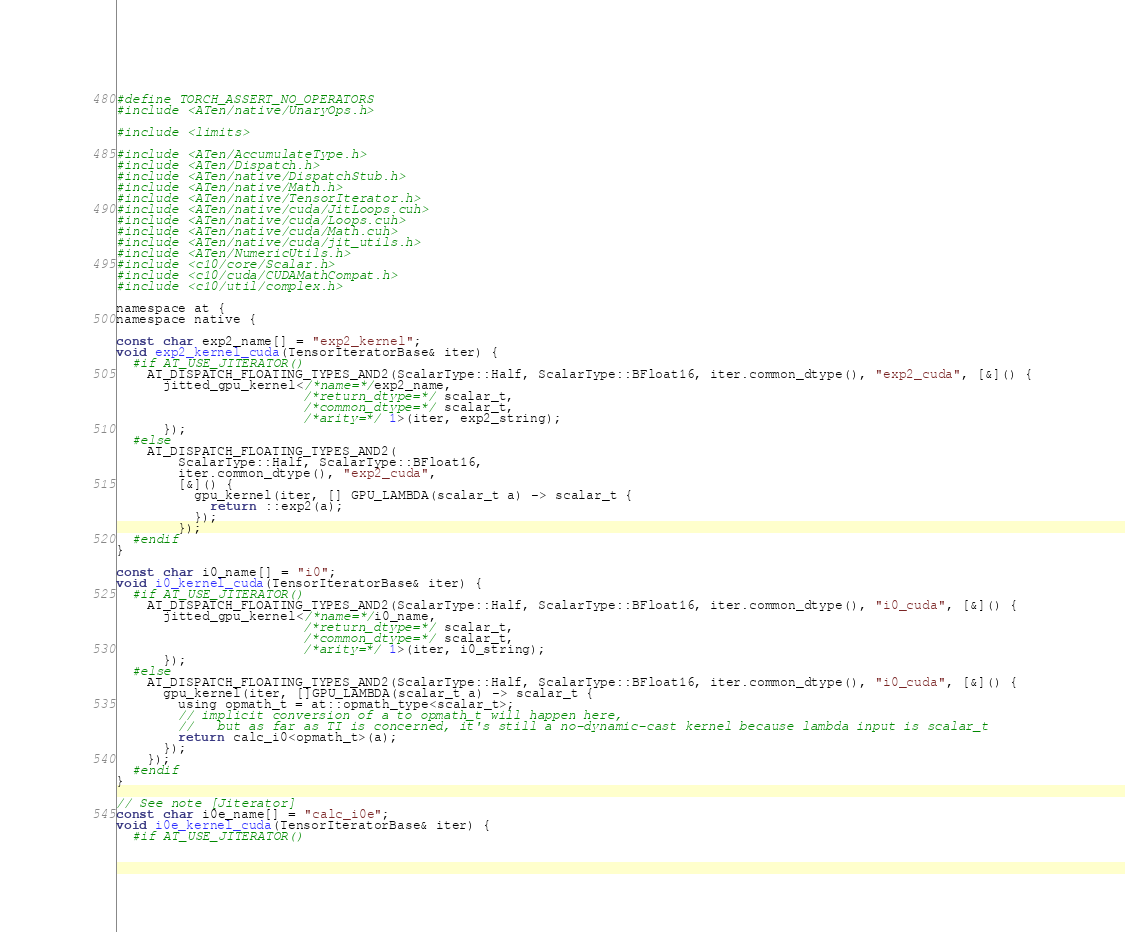<code> <loc_0><loc_0><loc_500><loc_500><_Cuda_>#define TORCH_ASSERT_NO_OPERATORS
#include <ATen/native/UnaryOps.h>

#include <limits>

#include <ATen/AccumulateType.h>
#include <ATen/Dispatch.h>
#include <ATen/native/DispatchStub.h>
#include <ATen/native/Math.h>
#include <ATen/native/TensorIterator.h>
#include <ATen/native/cuda/JitLoops.cuh>
#include <ATen/native/cuda/Loops.cuh>
#include <ATen/native/cuda/Math.cuh>
#include <ATen/native/cuda/jit_utils.h>
#include <ATen/NumericUtils.h>
#include <c10/core/Scalar.h>
#include <c10/cuda/CUDAMathCompat.h>
#include <c10/util/complex.h>

namespace at {
namespace native {

const char exp2_name[] = "exp2_kernel";
void exp2_kernel_cuda(TensorIteratorBase& iter) {
  #if AT_USE_JITERATOR()
    AT_DISPATCH_FLOATING_TYPES_AND2(ScalarType::Half, ScalarType::BFloat16, iter.common_dtype(), "exp2_cuda", [&]() {
      jitted_gpu_kernel</*name=*/exp2_name,
                        /*return_dtype=*/ scalar_t,
                        /*common_dtype=*/ scalar_t,
                        /*arity=*/ 1>(iter, exp2_string);
      });
  #else
    AT_DISPATCH_FLOATING_TYPES_AND2(
        ScalarType::Half, ScalarType::BFloat16,
        iter.common_dtype(), "exp2_cuda",
        [&]() {
          gpu_kernel(iter, [] GPU_LAMBDA(scalar_t a) -> scalar_t {
            return ::exp2(a);
          });
        });
  #endif
}

const char i0_name[] = "i0";
void i0_kernel_cuda(TensorIteratorBase& iter) {
  #if AT_USE_JITERATOR()
    AT_DISPATCH_FLOATING_TYPES_AND2(ScalarType::Half, ScalarType::BFloat16, iter.common_dtype(), "i0_cuda", [&]() {
      jitted_gpu_kernel</*name=*/i0_name,
                        /*return_dtype=*/ scalar_t,
                        /*common_dtype=*/ scalar_t,
                        /*arity=*/ 1>(iter, i0_string);
      });
  #else
    AT_DISPATCH_FLOATING_TYPES_AND2(ScalarType::Half, ScalarType::BFloat16, iter.common_dtype(), "i0_cuda", [&]() {
      gpu_kernel(iter, []GPU_LAMBDA(scalar_t a) -> scalar_t {
        using opmath_t = at::opmath_type<scalar_t>;
        // implicit conversion of a to opmath_t will happen here,
        //   but as far as TI is concerned, it's still a no-dynamic-cast kernel because lambda input is scalar_t
        return calc_i0<opmath_t>(a);
      });
    });
  #endif
}

// See note [Jiterator]
const char i0e_name[] = "calc_i0e";
void i0e_kernel_cuda(TensorIteratorBase& iter) {
  #if AT_USE_JITERATOR()</code> 